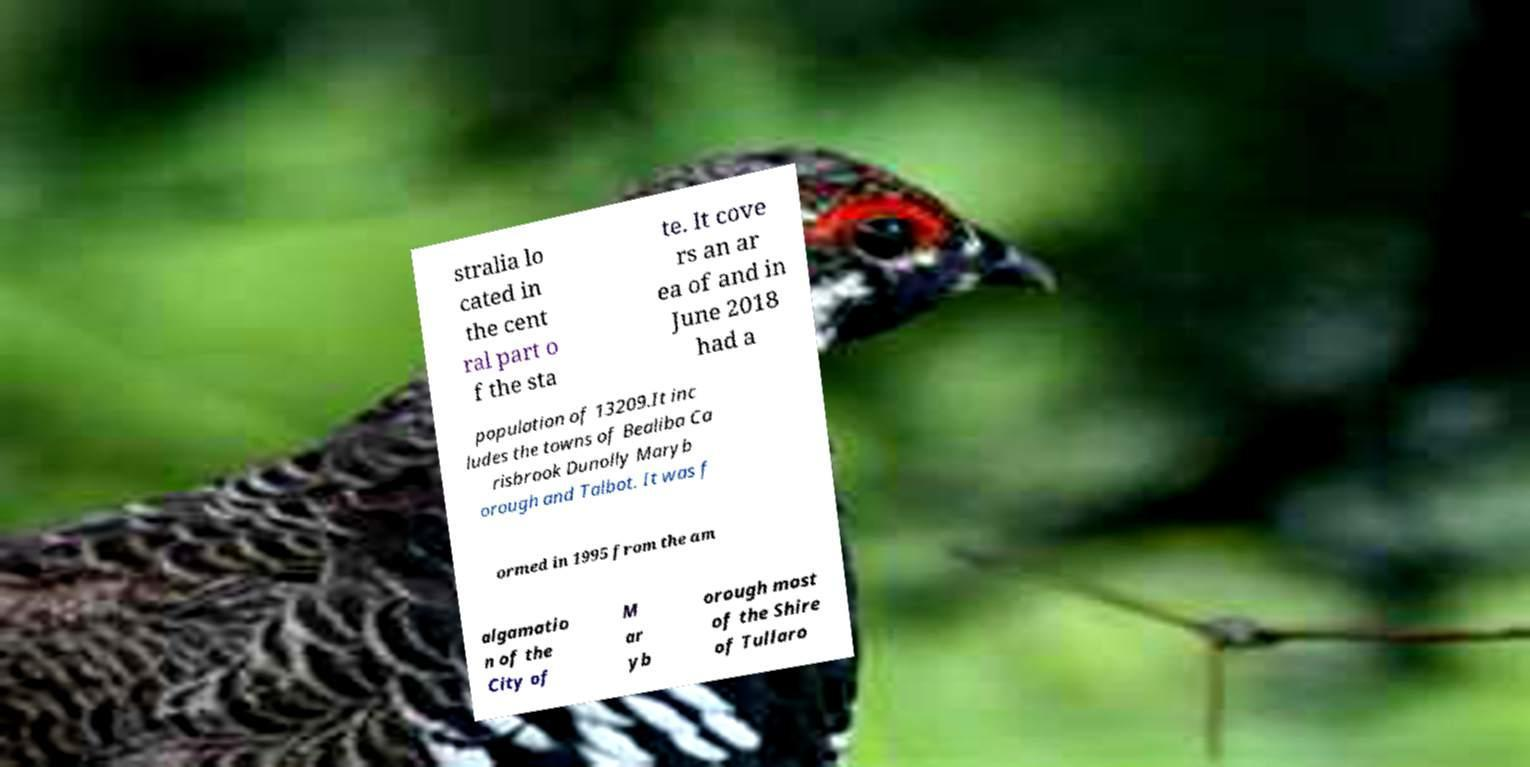Please read and relay the text visible in this image. What does it say? stralia lo cated in the cent ral part o f the sta te. It cove rs an ar ea of and in June 2018 had a population of 13209.It inc ludes the towns of Bealiba Ca risbrook Dunolly Maryb orough and Talbot. It was f ormed in 1995 from the am algamatio n of the City of M ar yb orough most of the Shire of Tullaro 